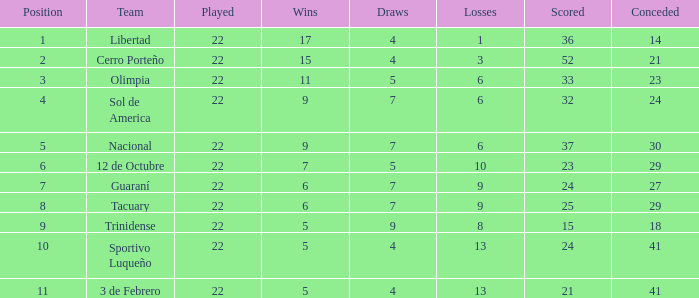What is the value scored when there were 19 points for the team 3 de Febrero? 21.0. 